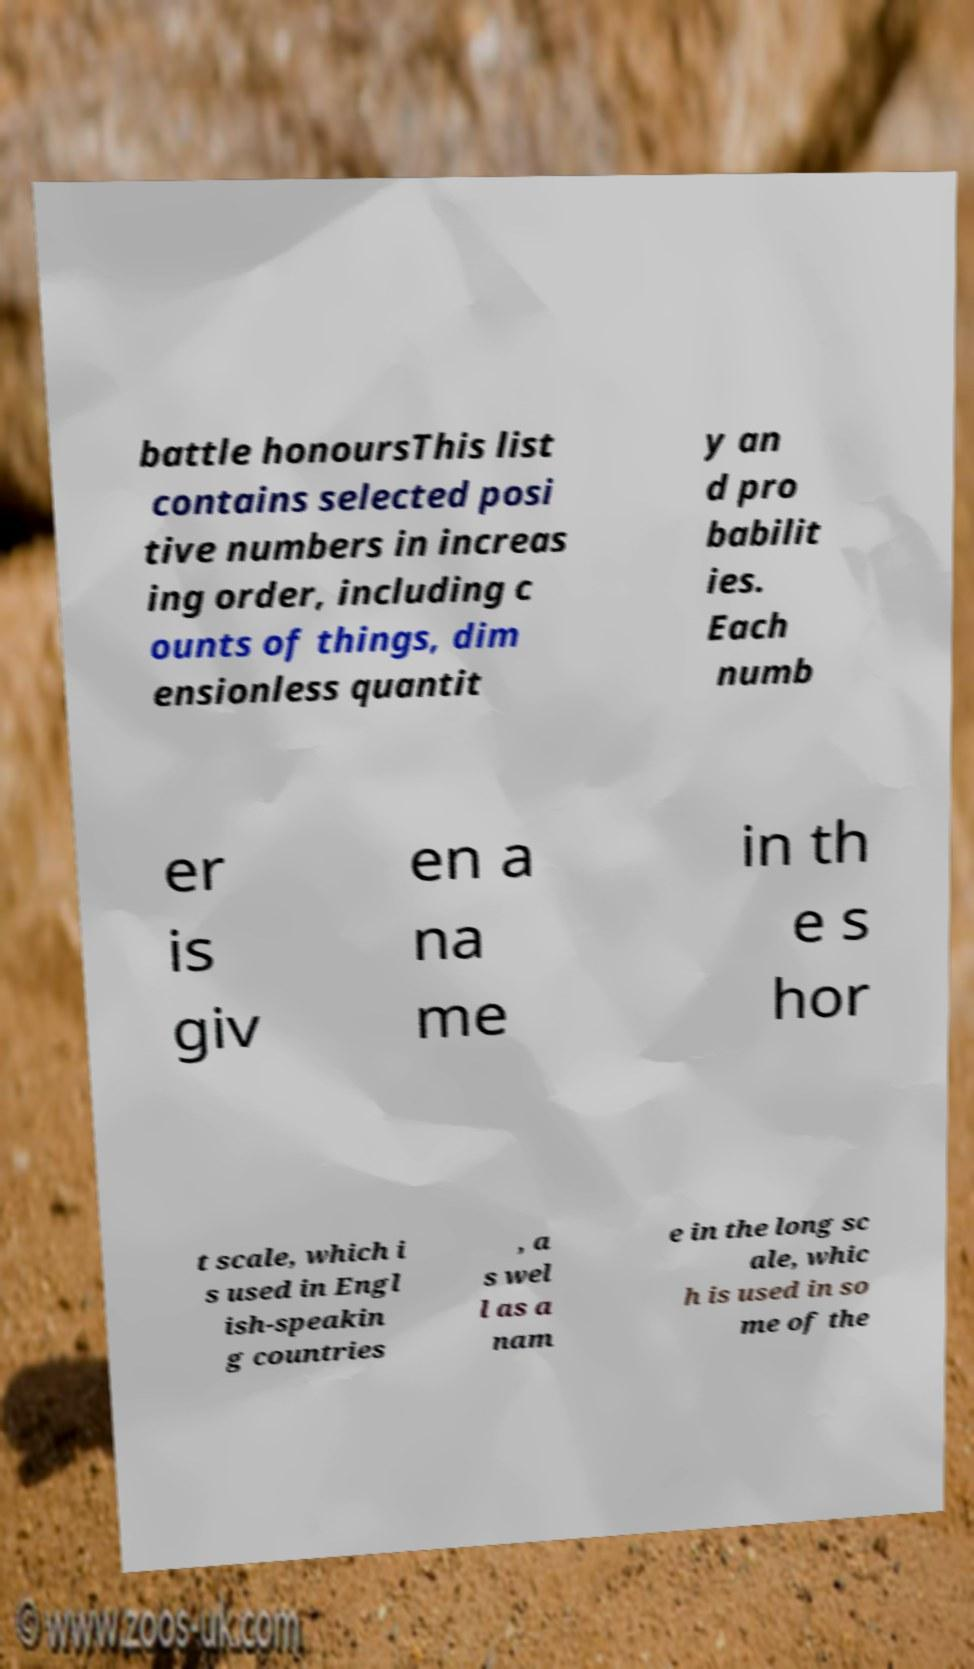Could you assist in decoding the text presented in this image and type it out clearly? battle honoursThis list contains selected posi tive numbers in increas ing order, including c ounts of things, dim ensionless quantit y an d pro babilit ies. Each numb er is giv en a na me in th e s hor t scale, which i s used in Engl ish-speakin g countries , a s wel l as a nam e in the long sc ale, whic h is used in so me of the 